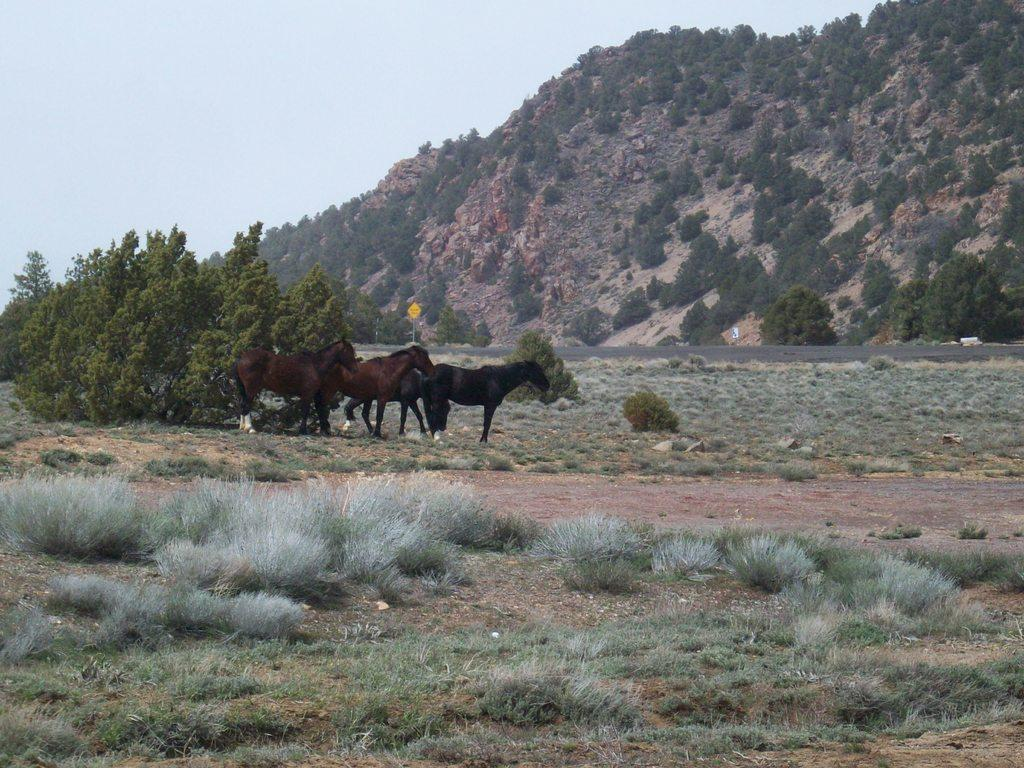How many horses are in the image? There are three brown horses in the image. What is the position of the horses in the image? The horses are standing in the ground. What type of vegetation is visible in the front side of the image? There are green plants in the front side of the image. What can be seen in the background of the image? There is a huge mountain with many trees in the background of the image. What type of bone can be seen sticking out of the ground in the image? There is no bone visible in the image; it features three brown horses standing in the ground with green plants in the front and a mountain with trees in the background. 